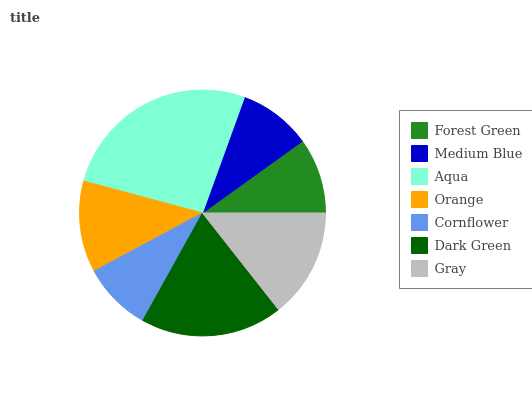Is Cornflower the minimum?
Answer yes or no. Yes. Is Aqua the maximum?
Answer yes or no. Yes. Is Medium Blue the minimum?
Answer yes or no. No. Is Medium Blue the maximum?
Answer yes or no. No. Is Forest Green greater than Medium Blue?
Answer yes or no. Yes. Is Medium Blue less than Forest Green?
Answer yes or no. Yes. Is Medium Blue greater than Forest Green?
Answer yes or no. No. Is Forest Green less than Medium Blue?
Answer yes or no. No. Is Orange the high median?
Answer yes or no. Yes. Is Orange the low median?
Answer yes or no. Yes. Is Gray the high median?
Answer yes or no. No. Is Gray the low median?
Answer yes or no. No. 